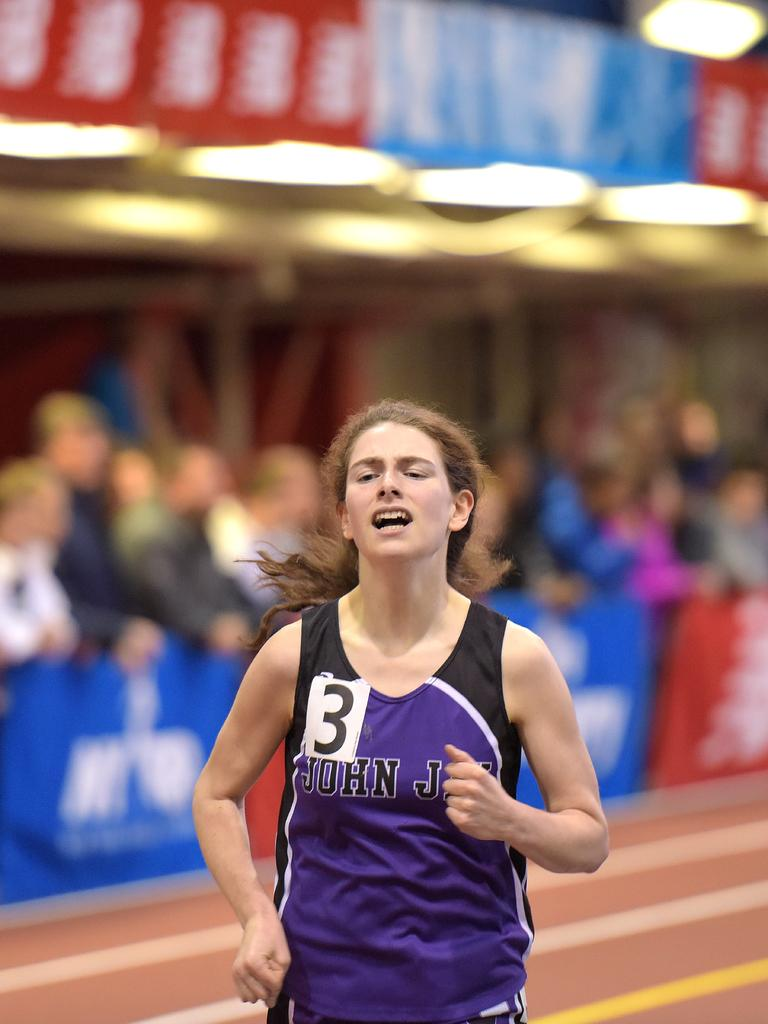<image>
Provide a brief description of the given image. Runner number 3 looks like she is very tired. 